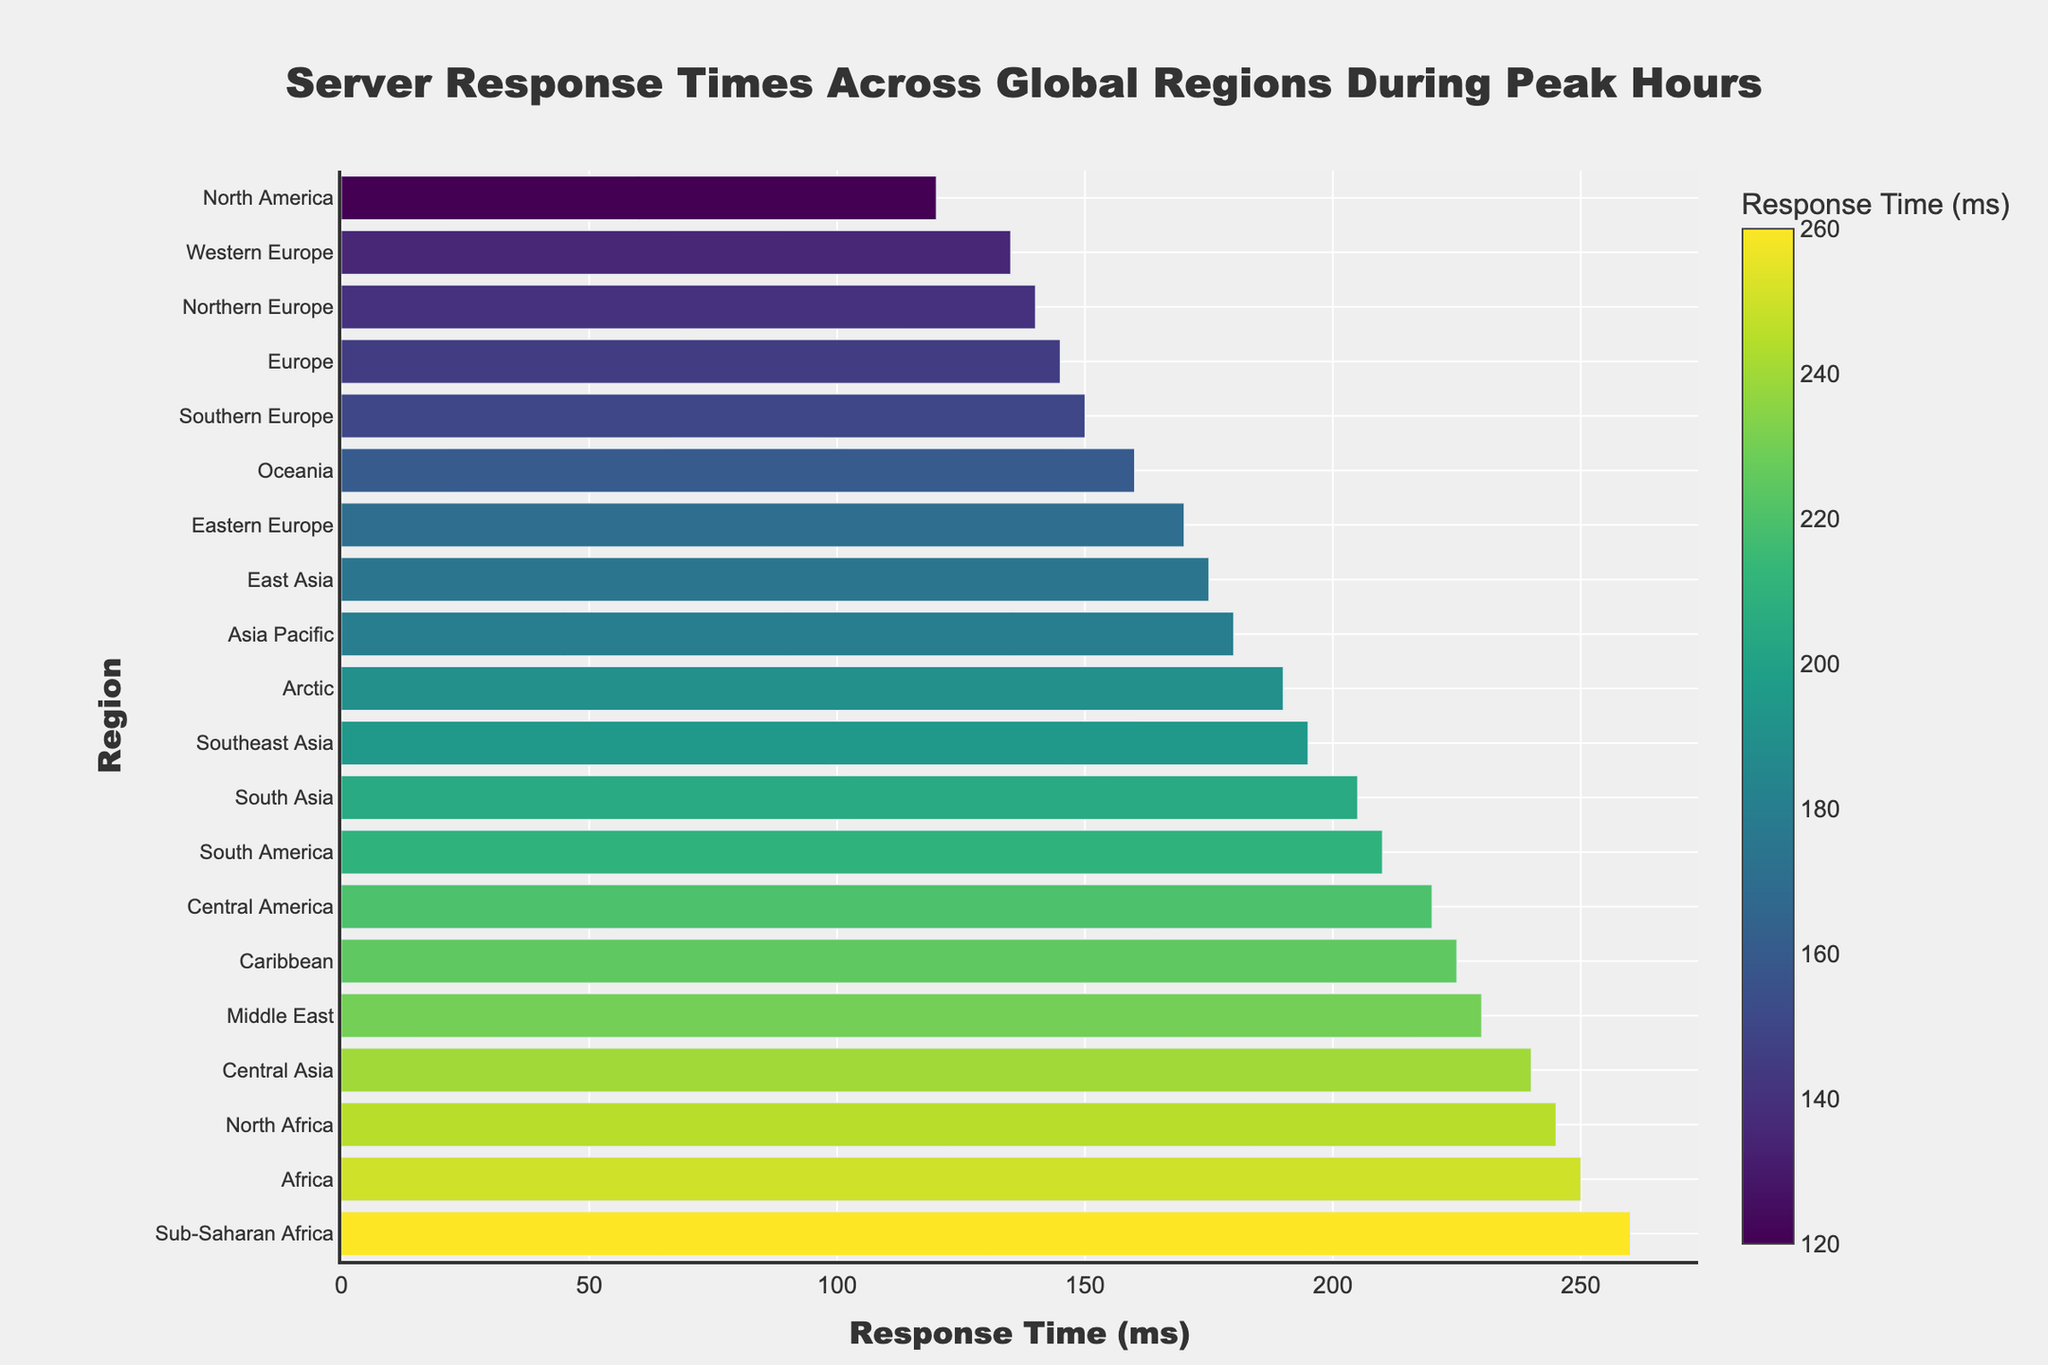Which region has the highest server response time? The bar chart shows different regions with their corresponding response times. The highest bar indicates the region with the highest server response time. From the chart, Sub-Saharan Africa has the highest server response time.
Answer: Sub-Saharan Africa Which regions have server response times above 200 ms? To find regions with response times above 200 ms, look at the bars that extend beyond the 200 ms mark on the x-axis. The regions that meet this criterion are South America, Middle East, Africa, Central America, Caribbean, Central Asia, North Africa, and Sub-Saharan Africa.
Answer: South America, Middle East, Africa, Central America, Caribbean, Central Asia, North Africa, Sub-Saharan Africa What is the difference in server response time between North America and Africa? To calculate the difference, subtract the response time of North America (120ms) from Africa (250ms) as shown in the chart. Therefore, the difference is 250 - 120 = 130 ms.
Answer: 130 ms Which region has a shorter server response time: Europe or Southeast Asia? Compare the bars for Europe and Southeast Asia. The collective regions in Europe (Western Europe, Northern Europe, Southern Europe, Eastern Europe) all have response times below 195 ms, which is the response time for Southeast Asia. Therefore, Europe has a shorter server response time.
Answer: Europe What is the median server response time across all regions? To find the median, list all server response times in ascending order and find the middle value. The ordered times are 120, 135, 140, 145, 150, 160, 170, 175, 180, 190, 195, 205, 210, 220, 225, 230, 240, 245, 250, 260. The median lies between the 10th and 11th values (190 and 195). The median is (190 + 195) / 2 = 192.5 ms.
Answer: 192.5 ms Which regions have server response times within the range of 150 ms to 200 ms? Examine the bars that fall between the 150 ms and 200 ms marks on the x-axis. The regions are Southern Europe, Oceania, Eastern Europe, East Asia, Arctic, and Southeast Asia.
Answer: Southern Europe, Oceania, Eastern Europe, East Asia, Arctic, Southeast Asia Is the response time for Asia Pacific greater than that of Oceania? Compare the bars for Asia Pacific and Oceania. Asia Pacific has a response time of 180 ms, while Oceania has a response time of 160 ms. Therefore, Asia Pacific's response time is greater.
Answer: Yes By how much does the server response time in Central America exceed that of Northern Europe? Find the response times for Central America and Northern Europe from the chart (220 ms and 140 ms, respectively). The difference is 220 - 140 = 80 ms.
Answer: 80 ms Which region has nearly the same server response time as the Middle East? Look for bars with lengths closest to the Middle East’s response time of 230 ms. North Africa has a response time of 245 ms, which is near to 230 ms.
Answer: North Africa 